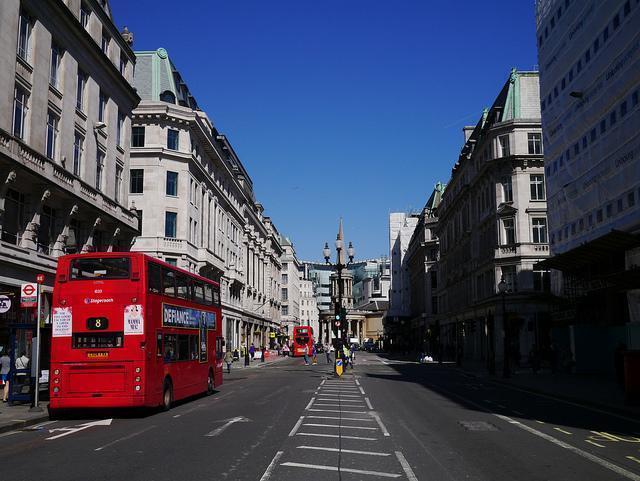How many double-decker buses are loading on the left side of the street?
From the following set of four choices, select the accurate answer to respond to the question.
Options: One, four, two, six. Two. 